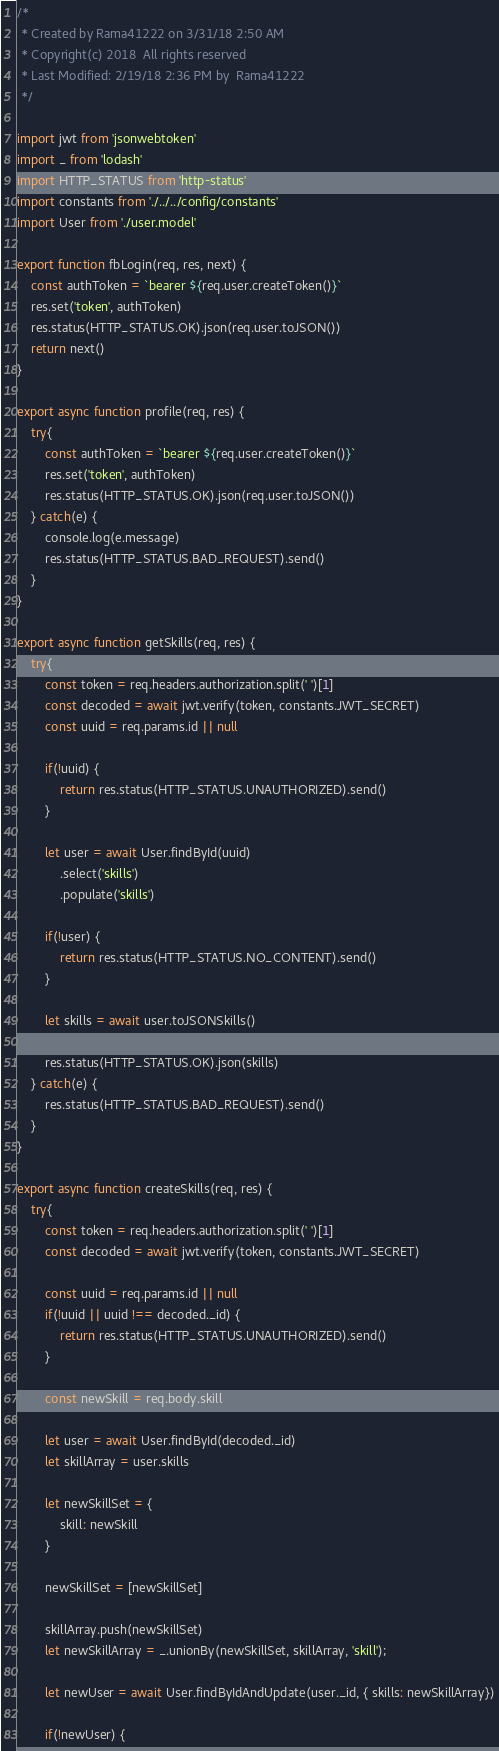<code> <loc_0><loc_0><loc_500><loc_500><_JavaScript_>/*
 * Created by Rama41222 on 3/31/18 2:50 AM
 * Copyright(c) 2018  All rights reserved
 * Last Modified: 2/19/18 2:36 PM by  Rama41222
 */

import jwt from 'jsonwebtoken'
import _ from 'lodash'
import HTTP_STATUS from 'http-status'
import constants from './../../config/constants'
import User from './user.model'

export function fbLogin(req, res, next) {
    const authToken = `bearer ${req.user.createToken()}`
    res.set('token', authToken)
    res.status(HTTP_STATUS.OK).json(req.user.toJSON())
    return next()
}

export async function profile(req, res) {
    try{
        const authToken = `bearer ${req.user.createToken()}`
        res.set('token', authToken)
        res.status(HTTP_STATUS.OK).json(req.user.toJSON())
    } catch(e) {
        console.log(e.message)
        res.status(HTTP_STATUS.BAD_REQUEST).send()
    }
}

export async function getSkills(req, res) {
    try{
        const token = req.headers.authorization.split(' ')[1]
        const decoded = await jwt.verify(token, constants.JWT_SECRET)
        const uuid = req.params.id || null

        if(!uuid) {
            return res.status(HTTP_STATUS.UNAUTHORIZED).send()
        }

        let user = await User.findById(uuid)
            .select('skills')
            .populate('skills')

        if(!user) {
            return res.status(HTTP_STATUS.NO_CONTENT).send()
        }

        let skills = await user.toJSONSkills()

        res.status(HTTP_STATUS.OK).json(skills)
    } catch(e) {
        res.status(HTTP_STATUS.BAD_REQUEST).send()
    }
}

export async function createSkills(req, res) {
    try{
        const token = req.headers.authorization.split(' ')[1]
        const decoded = await jwt.verify(token, constants.JWT_SECRET)

        const uuid = req.params.id || null
        if(!uuid || uuid !== decoded._id) {
            return res.status(HTTP_STATUS.UNAUTHORIZED).send()
        }

        const newSkill = req.body.skill

        let user = await User.findById(decoded._id)
        let skillArray = user.skills

        let newSkillSet = {
            skill: newSkill
        }

        newSkillSet = [newSkillSet]

        skillArray.push(newSkillSet)
        let newSkillArray = _.unionBy(newSkillSet, skillArray, 'skill');

        let newUser = await User.findByIdAndUpdate(user._id, { skills: newSkillArray})

        if(!newUser) {</code> 